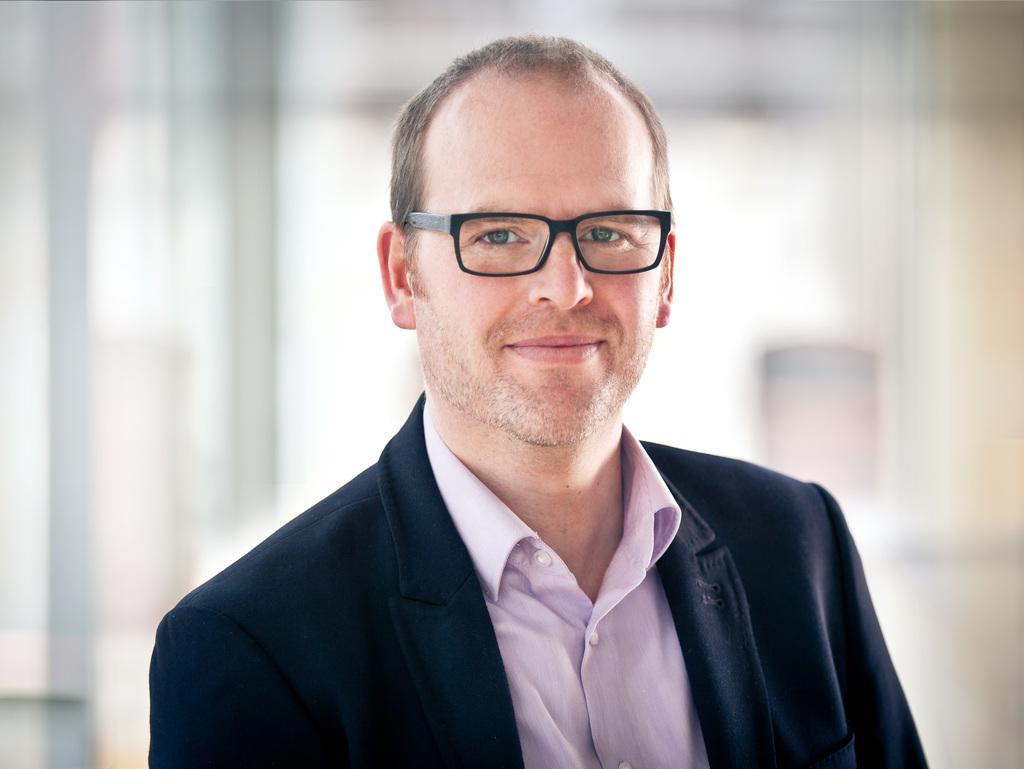Can you describe this image briefly? In this picture I can see there is a man standing, he is wearing a blazer, a purple shirt and he has spectacles and is smiling and the backdrop is blurred. 